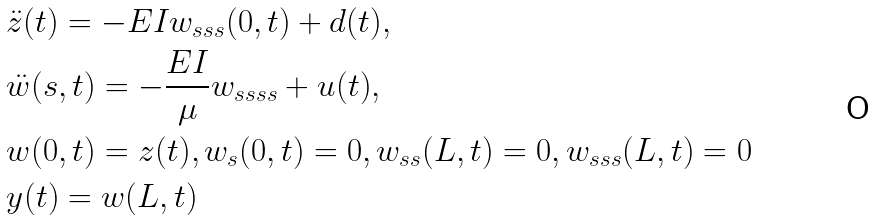Convert formula to latex. <formula><loc_0><loc_0><loc_500><loc_500>& \ddot { z } ( t ) = - E I w _ { s s s } ( 0 , t ) + d ( t ) , \\ & \ddot { w } ( s , t ) = - \frac { E I } { \mu } w _ { s s s s } + u ( t ) , \\ & w ( 0 , t ) = z ( t ) , w _ { s } ( 0 , t ) = 0 , w _ { s s } ( L , t ) = 0 , w _ { s s s } ( L , t ) = 0 \\ & y ( t ) = w ( L , t )</formula> 